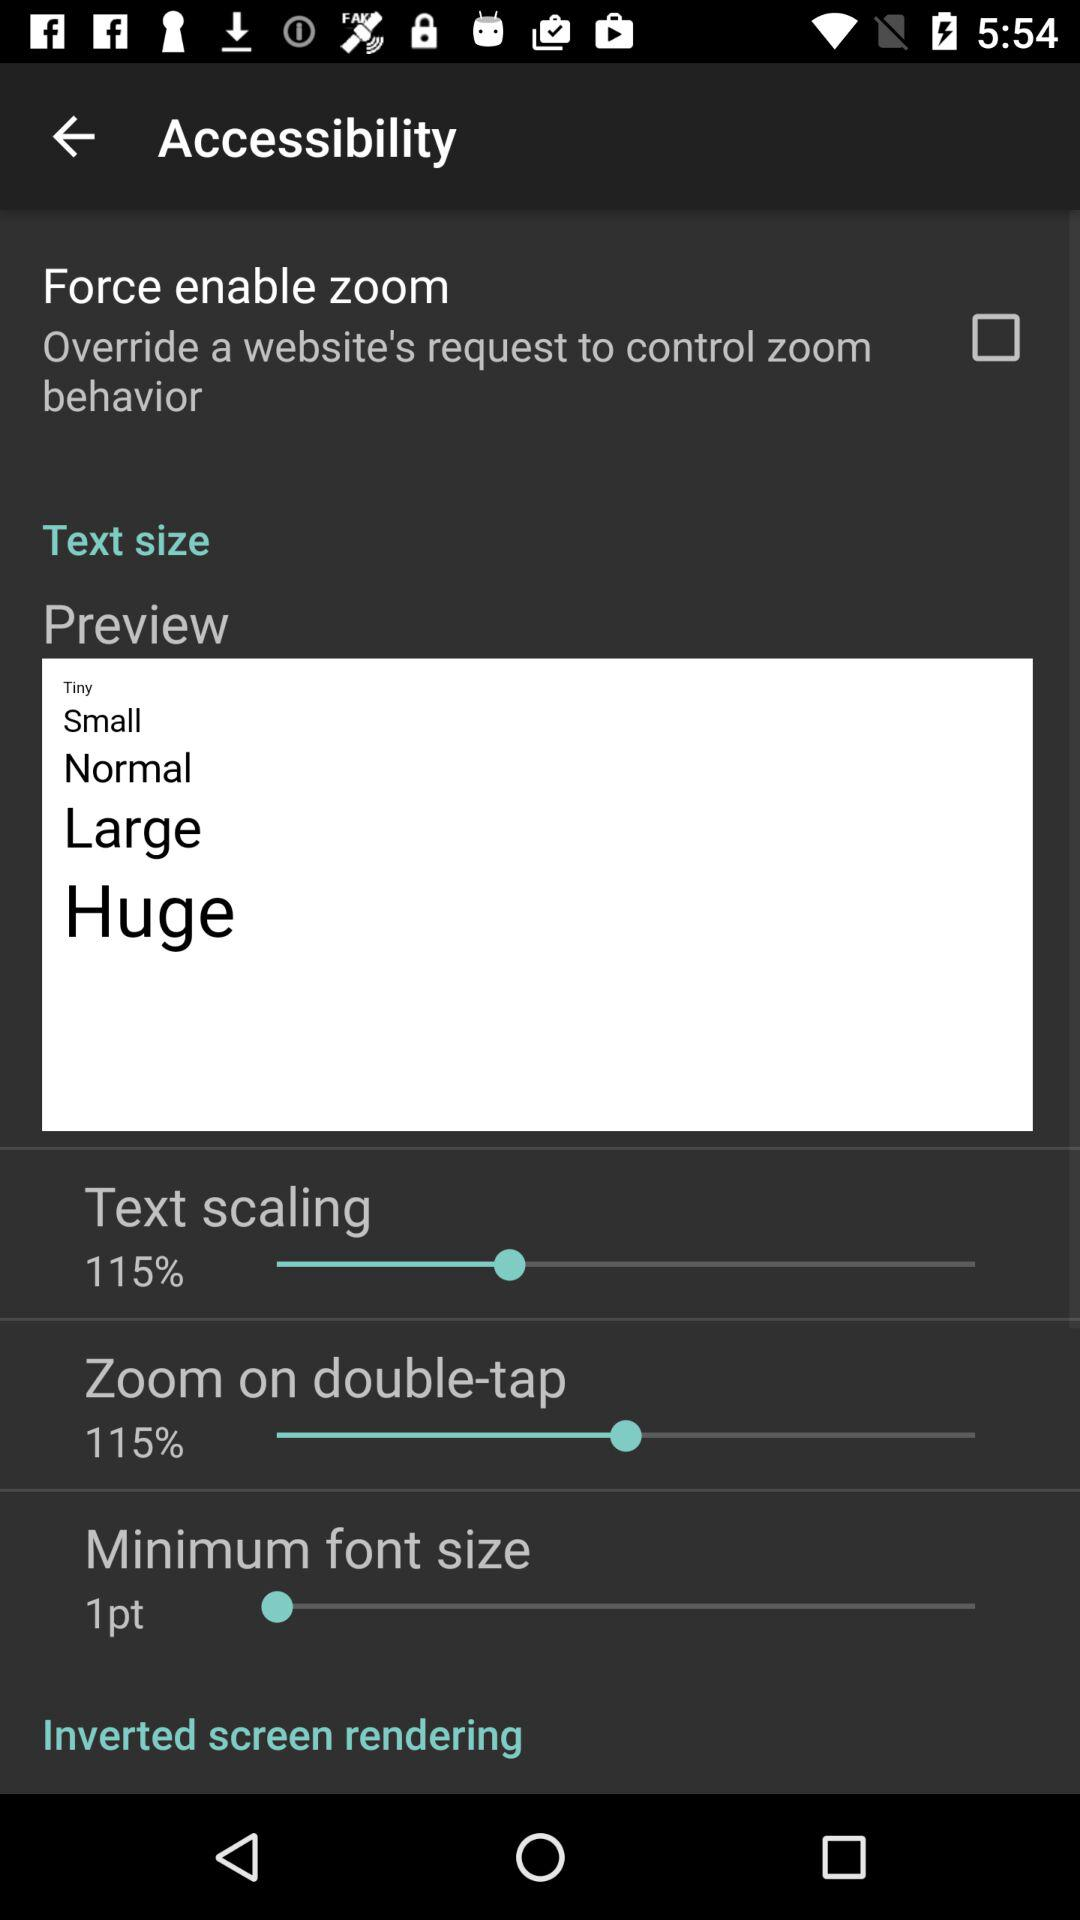How many text size options are available?
Answer the question using a single word or phrase. 5 